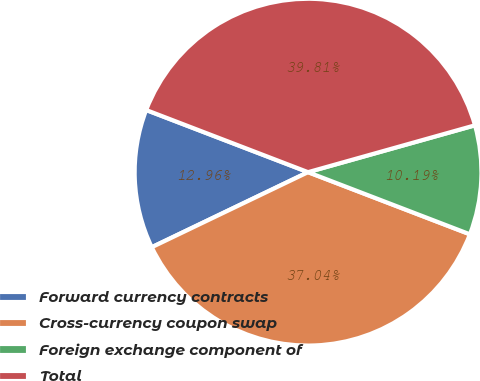<chart> <loc_0><loc_0><loc_500><loc_500><pie_chart><fcel>Forward currency contracts<fcel>Cross-currency coupon swap<fcel>Foreign exchange component of<fcel>Total<nl><fcel>12.96%<fcel>37.04%<fcel>10.19%<fcel>39.81%<nl></chart> 